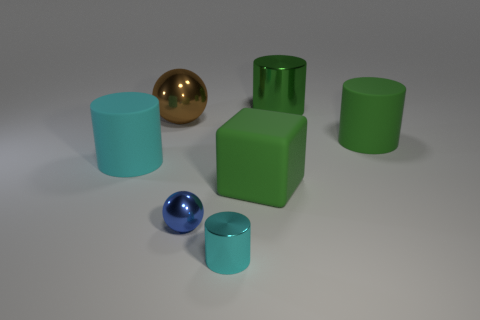Add 2 large green blocks. How many objects exist? 9 Subtract all cylinders. How many objects are left? 3 Add 1 cyan shiny cylinders. How many cyan shiny cylinders exist? 2 Subtract 1 blue balls. How many objects are left? 6 Subtract all green metallic cylinders. Subtract all big green rubber blocks. How many objects are left? 5 Add 7 tiny objects. How many tiny objects are left? 9 